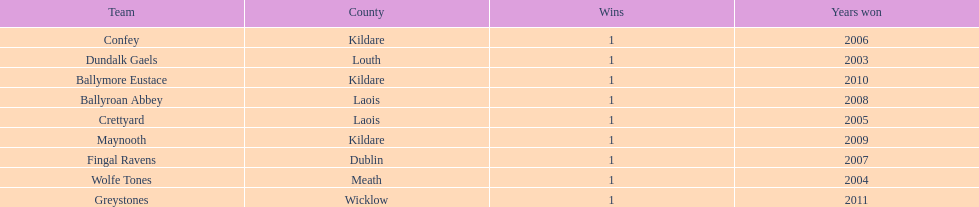Where is ballymore eustace from? Kildare. What teams other than ballymore eustace is from kildare? Maynooth, Confey. Between maynooth and confey, which won in 2009? Maynooth. 